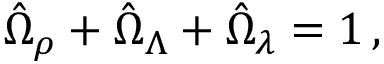<formula> <loc_0><loc_0><loc_500><loc_500>\hat { \Omega } _ { \rho } + \hat { \Omega } _ { \Lambda } + \hat { \Omega } _ { \lambda } = 1 \, ,</formula> 